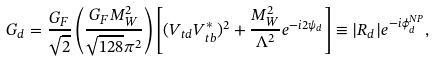Convert formula to latex. <formula><loc_0><loc_0><loc_500><loc_500>G _ { d } = \frac { G _ { F } } { \sqrt { 2 } } \left ( \frac { G _ { F } M _ { W } ^ { 2 } } { \sqrt { 1 2 8 } \pi ^ { 2 } } \right ) \left [ ( V _ { t d } V _ { t b } ^ { \ast } ) ^ { 2 } + \frac { M _ { W } ^ { 2 } } { \Lambda ^ { 2 } } e ^ { - i 2 \psi _ { d } } \right ] \equiv | R _ { d } | e ^ { - i \phi _ { d } ^ { N P } } ,</formula> 